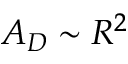Convert formula to latex. <formula><loc_0><loc_0><loc_500><loc_500>A _ { D } \sim R ^ { 2 }</formula> 